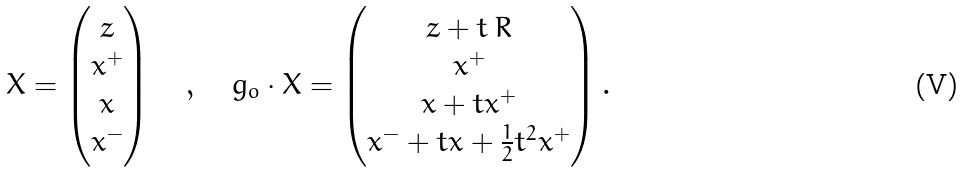Convert formula to latex. <formula><loc_0><loc_0><loc_500><loc_500>X = \begin{pmatrix} z \\ x ^ { + } \\ x \\ x ^ { - } \end{pmatrix} \quad , \quad g _ { o } \cdot X = \begin{pmatrix} z + t \, R \\ x ^ { + } \\ x + t x ^ { + } \\ x ^ { - } + t x + \frac { 1 } { 2 } t ^ { 2 } x ^ { + } \end{pmatrix} .</formula> 